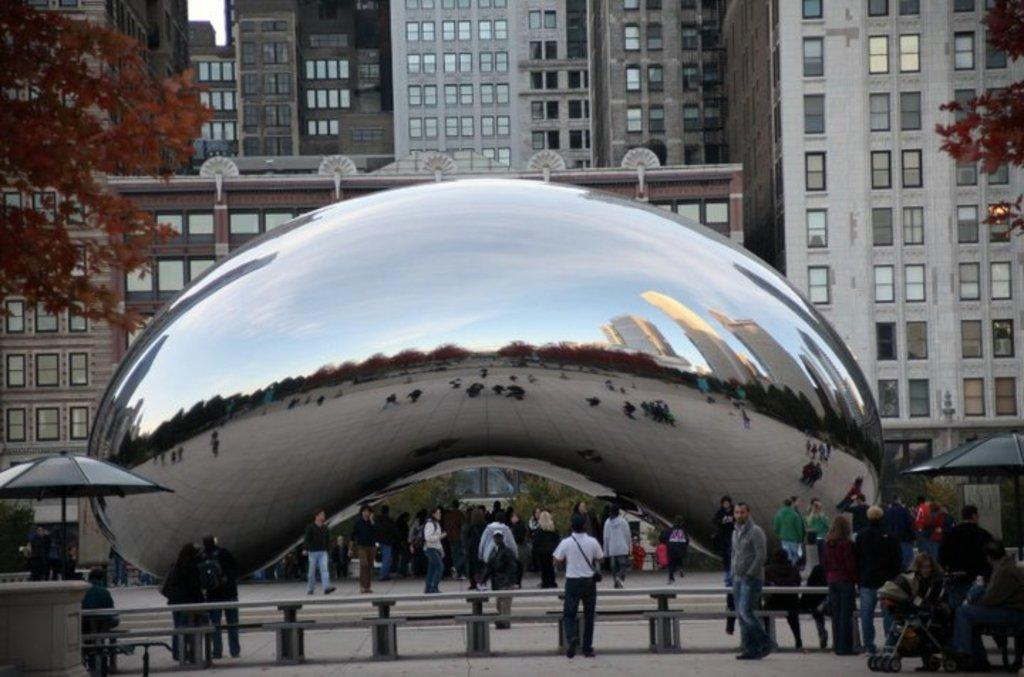Who or what can be seen in the image? There are people in the image. What objects are being used by the people in the image? Umbrellas are present in the image. What can be observed on the glass in the image? There is a reflection on the glass in the image. What elements are included in the reflection? The reflection includes people, trees, buildings, and sky. What type of vegetation is visible in the image? Trees are visible in the image. What structures can be seen in the background of the image? There are buildings in the background of the image. What part of the natural environment is visible in the background of the image? The sky is visible in the background of the image. What type of books can be seen on the ground in the image? There are no books present in the image. What kind of chalk drawings can be seen on the sidewalk in the image? There is no mention of chalk or drawings on the sidewalk in the image. 